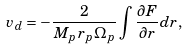<formula> <loc_0><loc_0><loc_500><loc_500>v _ { d } = - \frac { 2 } { M _ { p } r _ { p } \Omega _ { p } } \int \frac { \partial F } { \partial r } d r ,</formula> 